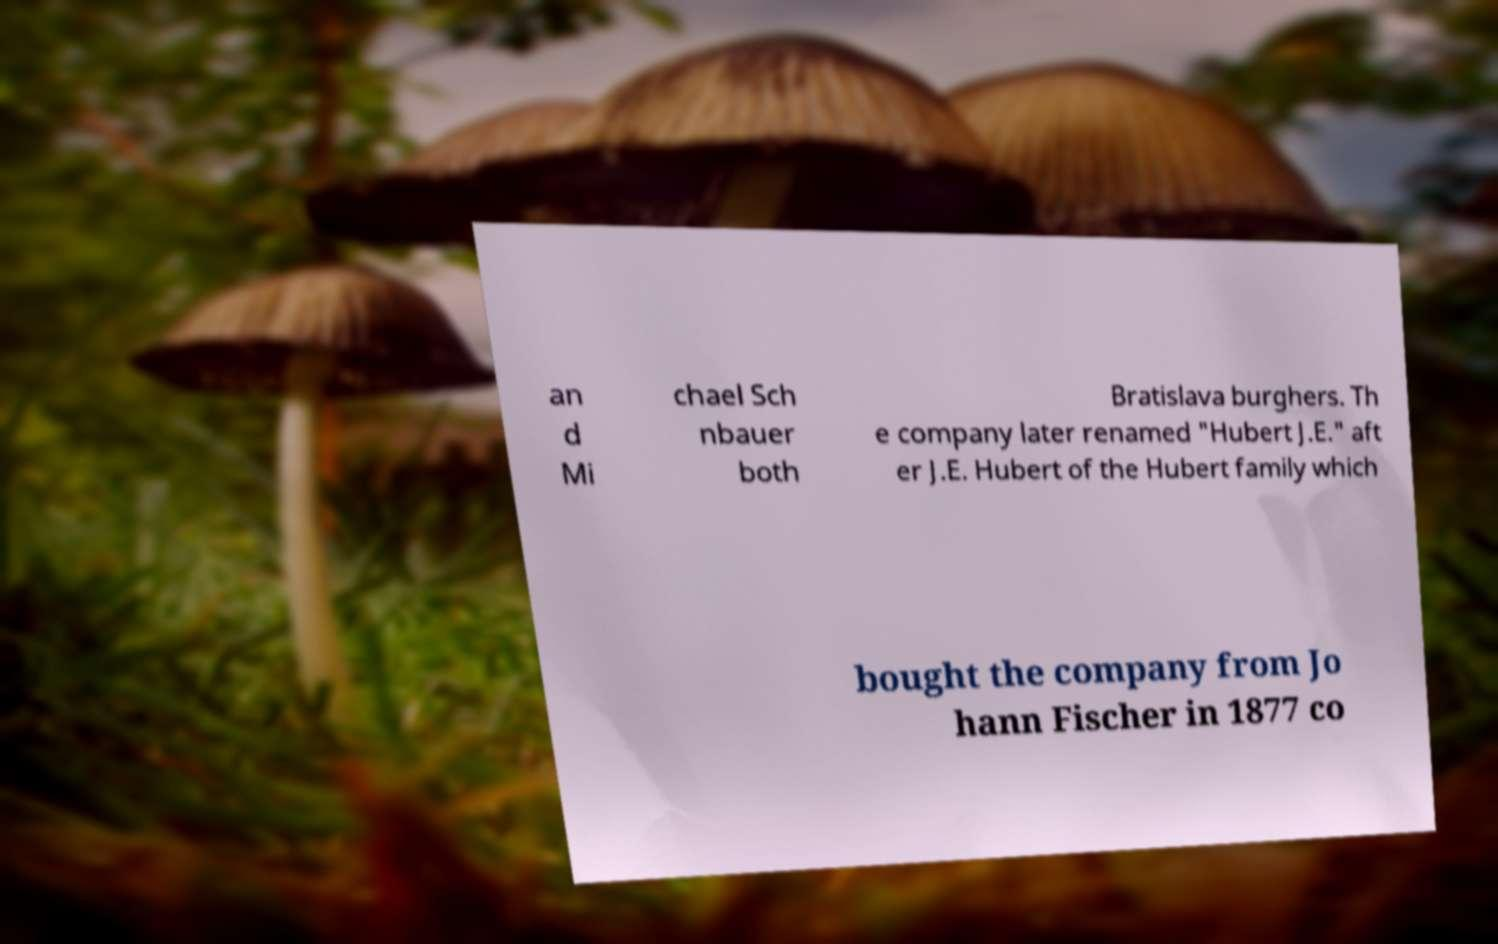Could you extract and type out the text from this image? an d Mi chael Sch nbauer both Bratislava burghers. Th e company later renamed "Hubert J.E." aft er J.E. Hubert of the Hubert family which bought the company from Jo hann Fischer in 1877 co 